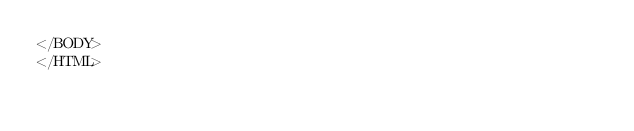Convert code to text. <code><loc_0><loc_0><loc_500><loc_500><_HTML_></BODY>
</HTML>
</code> 